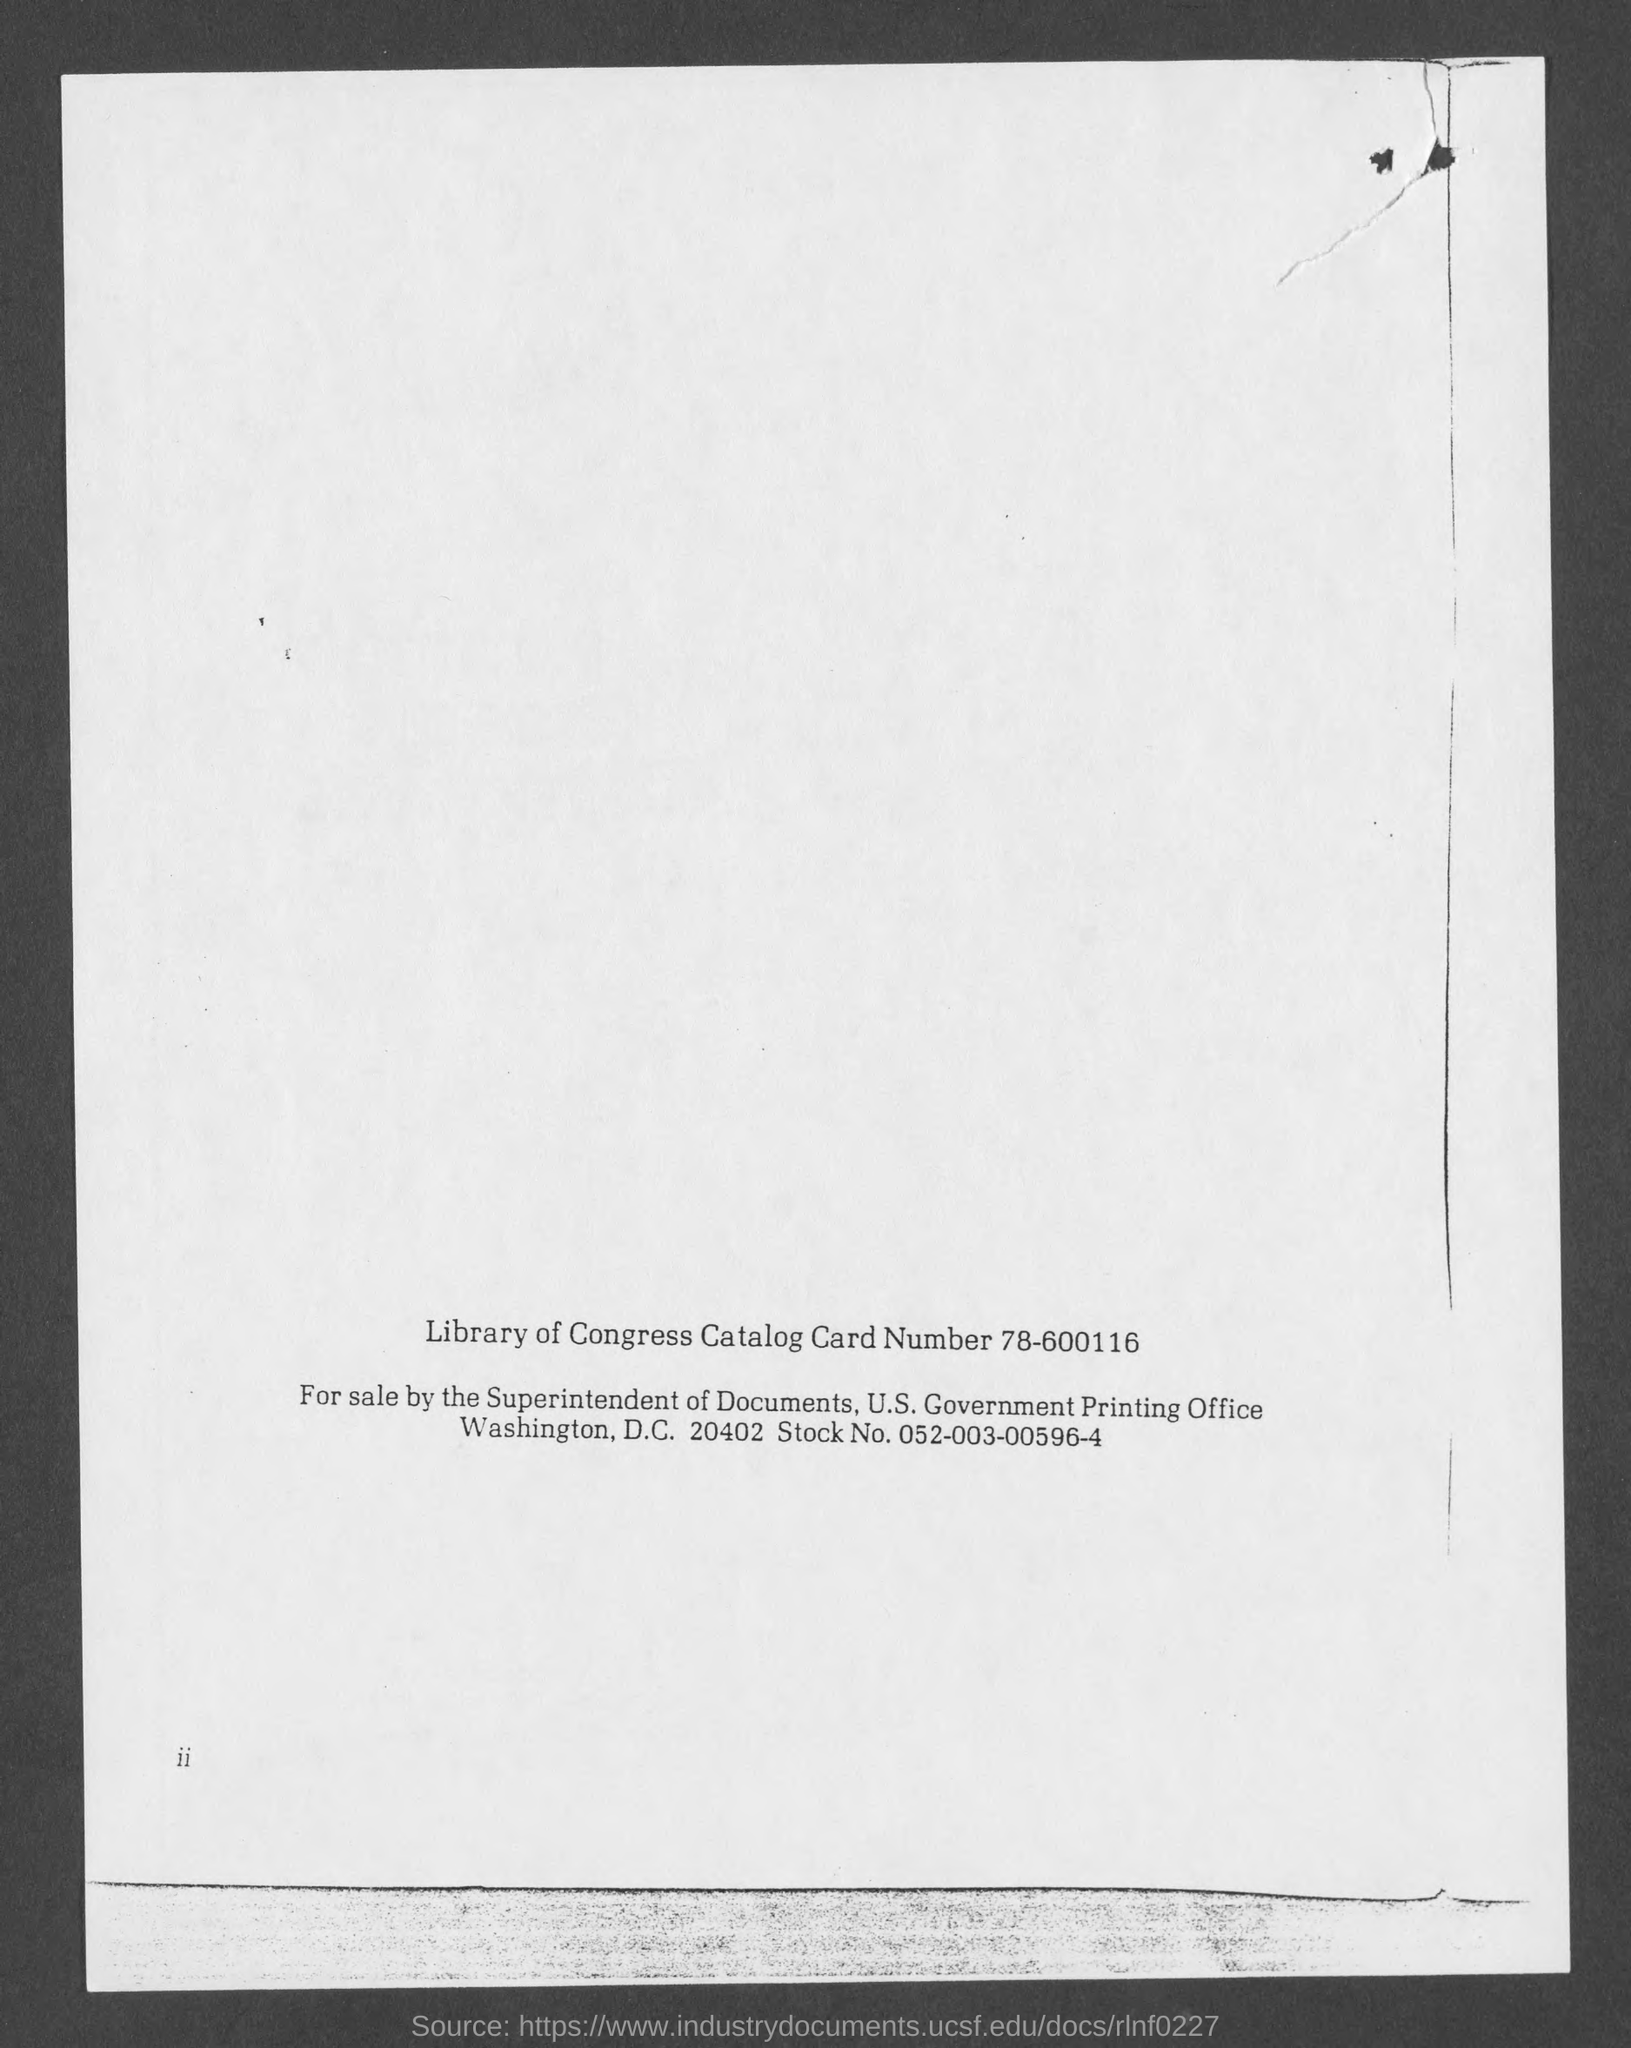What is the library of congress catalog card number ?
Give a very brief answer. 78-600116. What is stock no. ?
Provide a succinct answer. 052-003-00596-4. 